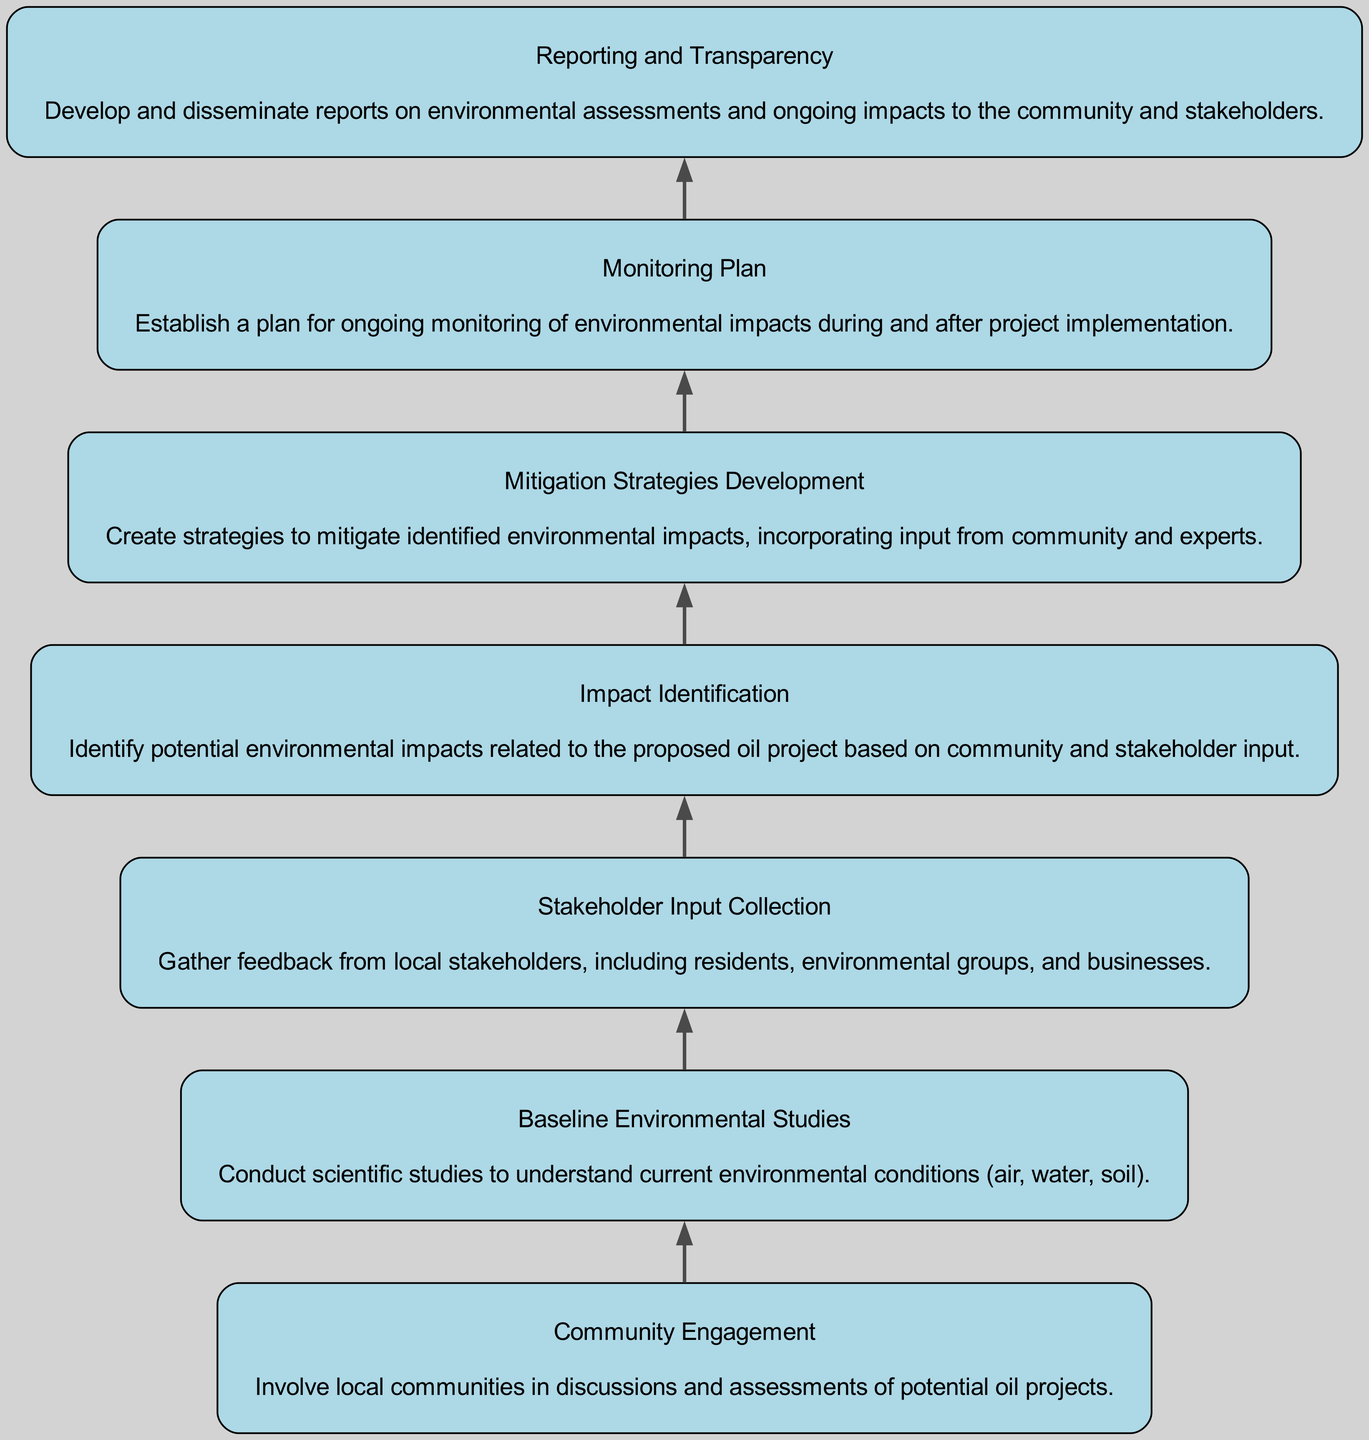What is the first step in the bottom-up approach? The first step, as represented in the diagram, is "Community Engagement". This is the initial node and indicates the starting point of the assessment process.
Answer: Community Engagement How many total elements are shown in the diagram? There are seven elements in the diagram, as indicated by the nodes that represent community engagement, baseline studies, stakeholder input collection, impact identification, mitigation strategies development, monitoring plan, and reporting and transparency.
Answer: Seven What follows the "Stakeholder Input Collection" node? The node that follows "Stakeholder Input Collection" is "Impact Identification". This indicates the flow from gathering input to identifying potential impacts.
Answer: Impact Identification Which step focuses on creating strategies for identified impacts? The step that focuses on creating strategies for the identified impacts is "Mitigation Strategies Development". This step aims to address the impacts identified earlier in the process.
Answer: Mitigation Strategies Development Is "Monitoring Plan" a final step in the diagram? No, "Monitoring Plan" is not a final step. It is followed by "Reporting and Transparency", indicating that monitoring is part of ongoing activities after the implementation of the project assessments.
Answer: No What two nodes are connected directly to the "Impact Identification" node? The "Impact Identification" node is directly connected to "Stakeholder Input Collection" (preceding it) and "Mitigation Strategies Development" (following it). This shows the flow from identifying impacts to developing mitigation strategies.
Answer: Stakeholder Input Collection and Mitigation Strategies Development Which element encompasses feedback from local stakeholders? The element that encompasses feedback from local stakeholders is "Stakeholder Input Collection". This step involves gathering input from nearby communities and associated groups regarding the potential oil project.
Answer: Stakeholder Input Collection What type of stakeholders is involved in "Community Engagement"? "Community Engagement" involves local communities, which encompasses residents, businesses, and local organizations that might be affected by the oil project.
Answer: Local communities What process is established for ongoing assessments after project implementation? The process established for ongoing assessments is represented by the "Monitoring Plan". This is critical for tracking the environmental impact during and after the project's execution.
Answer: Monitoring Plan 